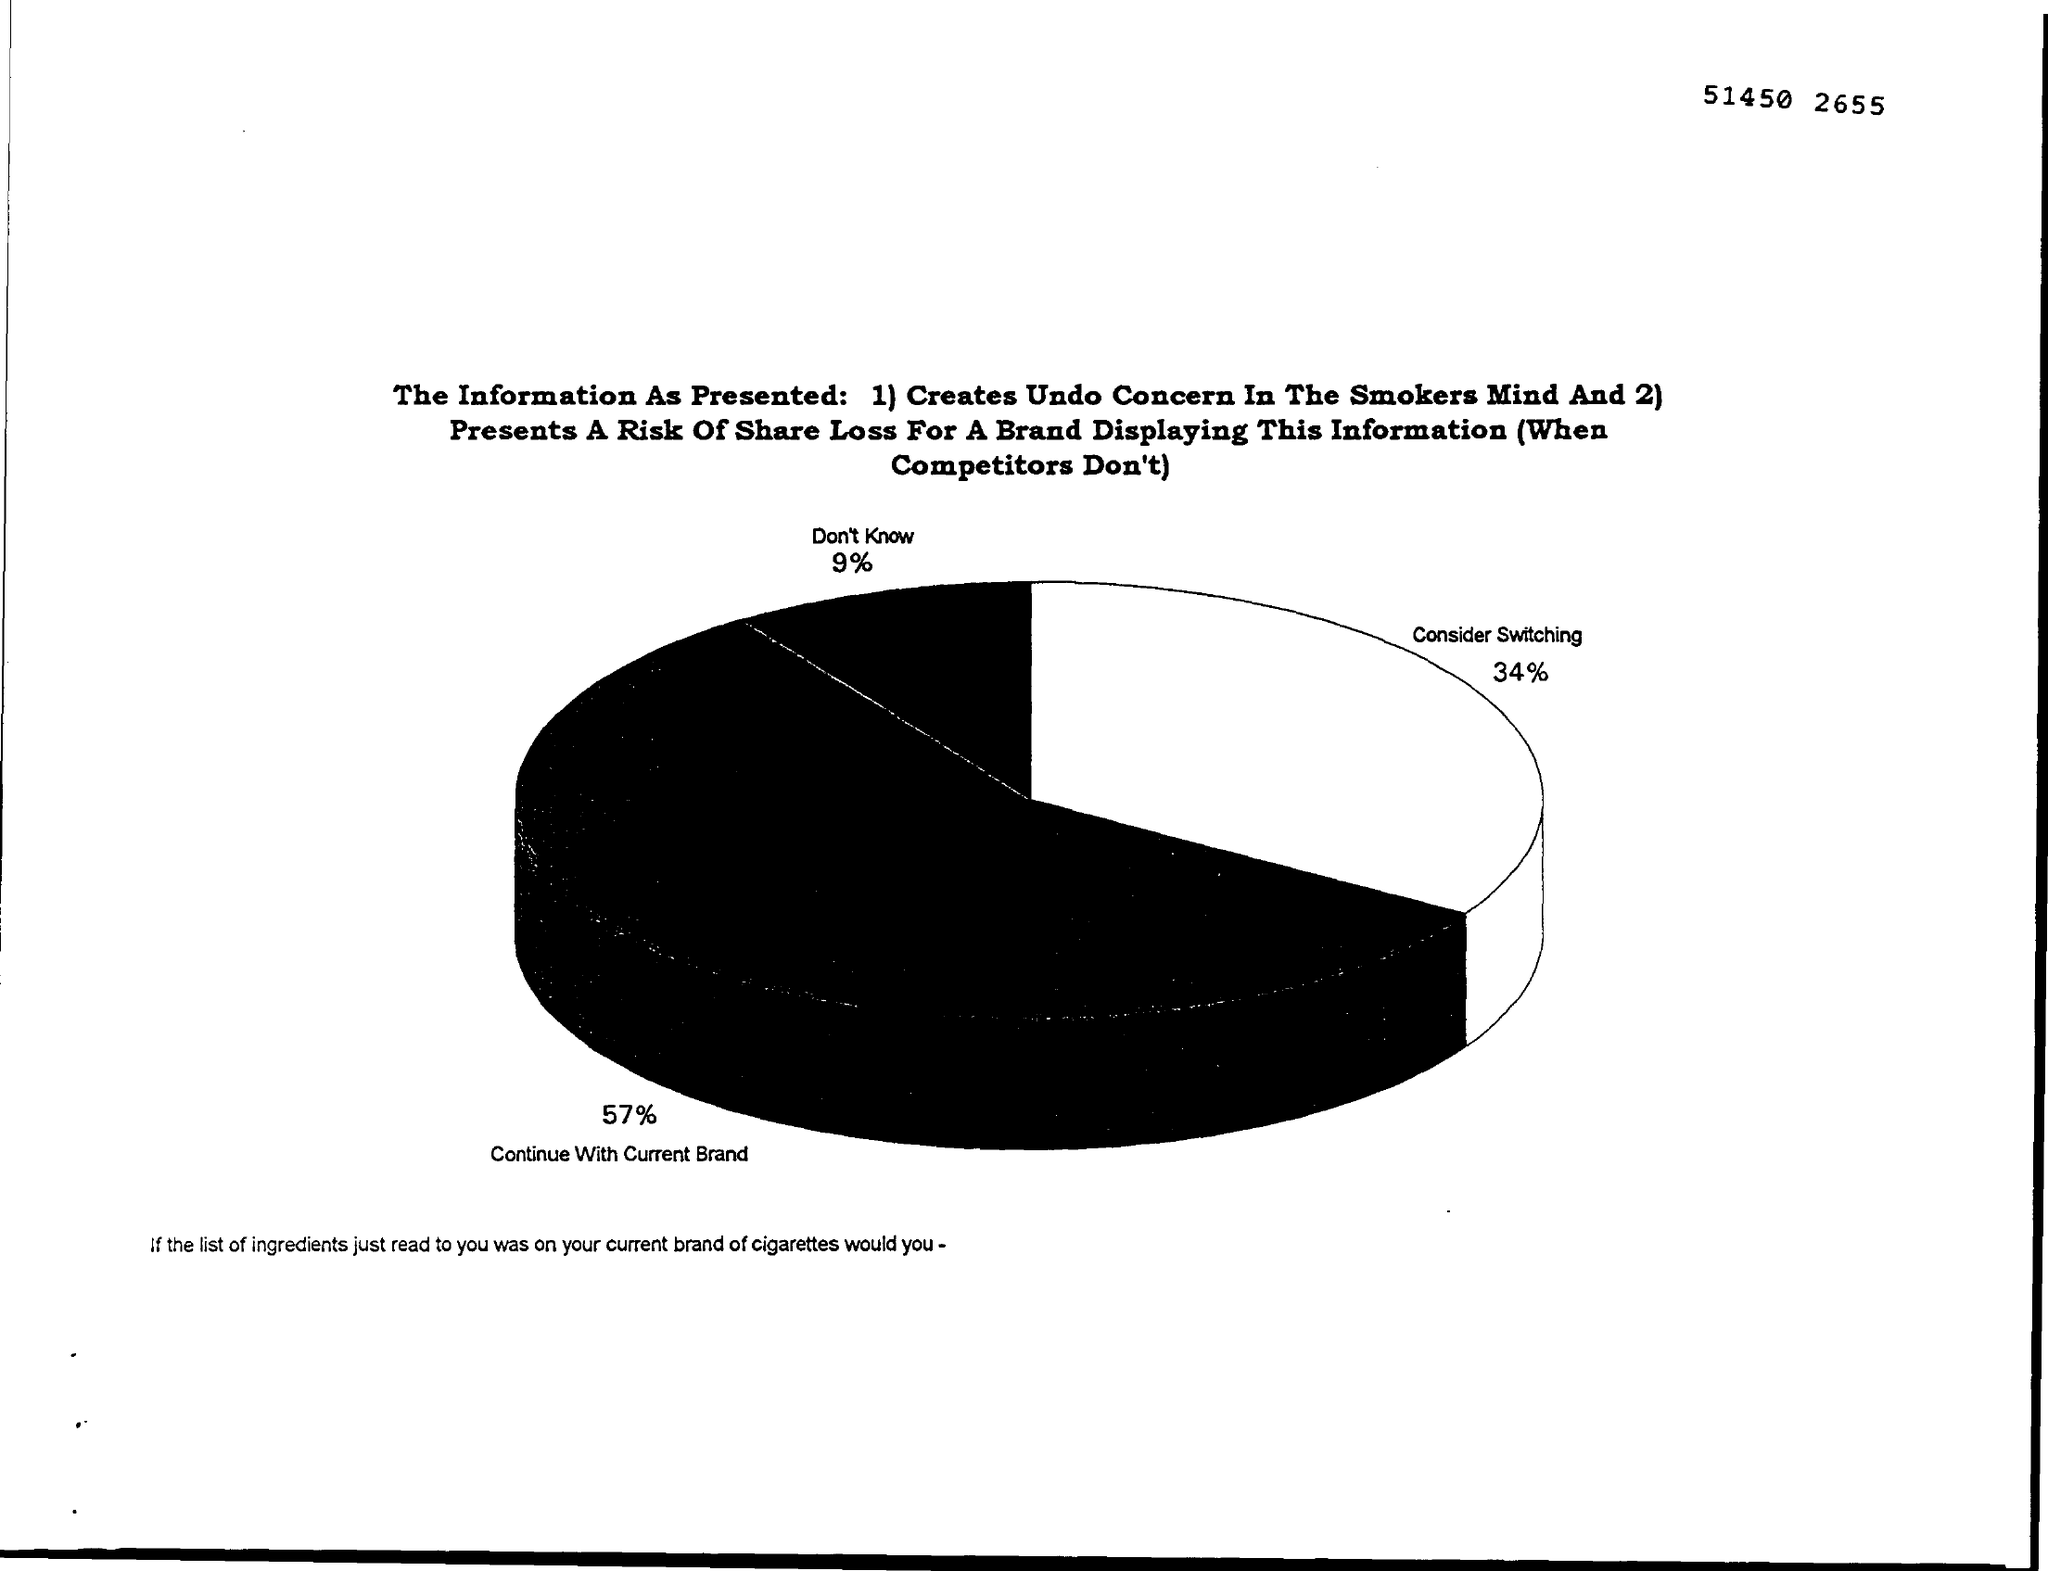What is the % that Consider switching?
Ensure brevity in your answer.  34%. What is the % that wants to Continue with current Brand?
Provide a short and direct response. 57. 